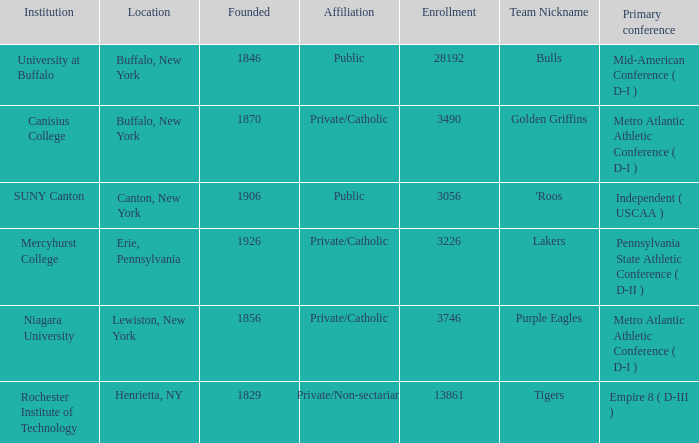What type of educational institution is canton, new york? Public. 